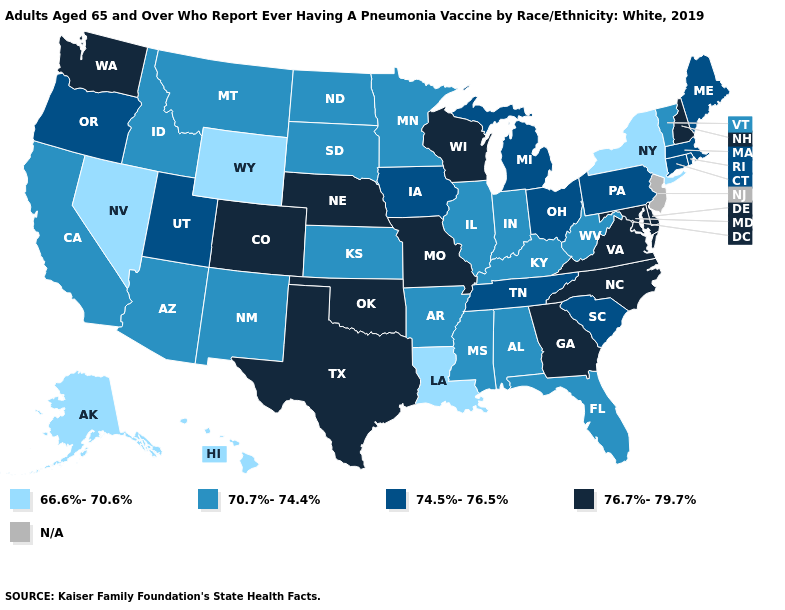Name the states that have a value in the range 74.5%-76.5%?
Give a very brief answer. Connecticut, Iowa, Maine, Massachusetts, Michigan, Ohio, Oregon, Pennsylvania, Rhode Island, South Carolina, Tennessee, Utah. What is the lowest value in the USA?
Answer briefly. 66.6%-70.6%. Does the first symbol in the legend represent the smallest category?
Concise answer only. Yes. Does Maryland have the highest value in the South?
Answer briefly. Yes. What is the highest value in the MidWest ?
Keep it brief. 76.7%-79.7%. What is the value of Wyoming?
Short answer required. 66.6%-70.6%. Name the states that have a value in the range N/A?
Keep it brief. New Jersey. Name the states that have a value in the range 76.7%-79.7%?
Give a very brief answer. Colorado, Delaware, Georgia, Maryland, Missouri, Nebraska, New Hampshire, North Carolina, Oklahoma, Texas, Virginia, Washington, Wisconsin. Name the states that have a value in the range 76.7%-79.7%?
Write a very short answer. Colorado, Delaware, Georgia, Maryland, Missouri, Nebraska, New Hampshire, North Carolina, Oklahoma, Texas, Virginia, Washington, Wisconsin. What is the value of Virginia?
Quick response, please. 76.7%-79.7%. Does the map have missing data?
Quick response, please. Yes. What is the value of Washington?
Write a very short answer. 76.7%-79.7%. What is the lowest value in states that border Texas?
Concise answer only. 66.6%-70.6%. What is the lowest value in the Northeast?
Keep it brief. 66.6%-70.6%. 